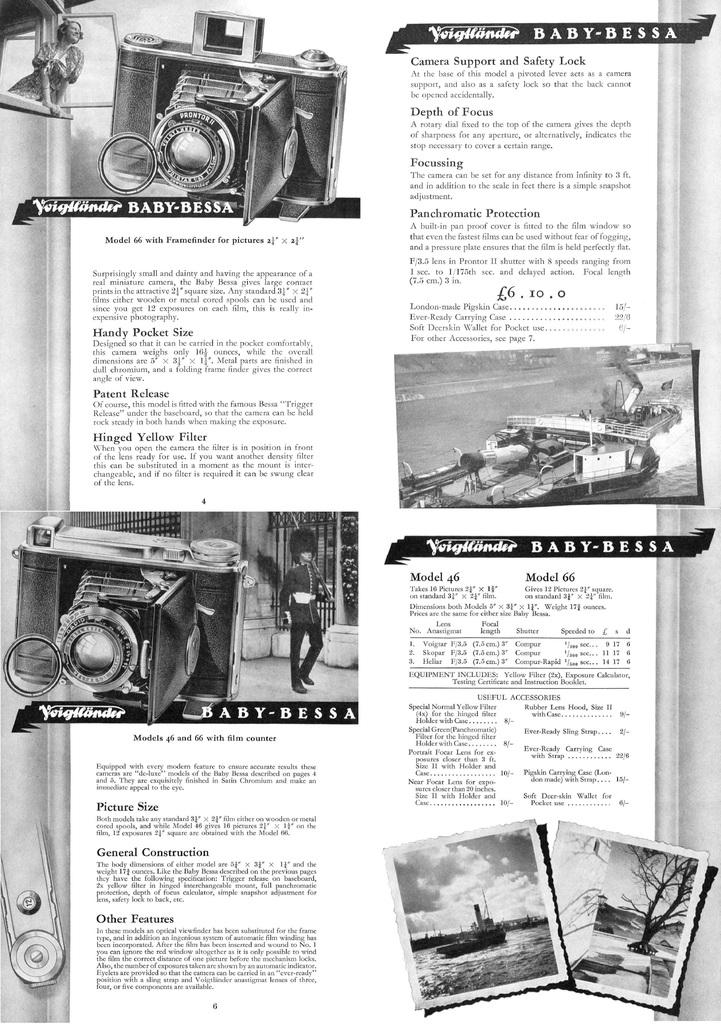What is the color scheme of the image? The image is black and white. What type of object with text can be seen in the image? There is a paper with text in the image. What else is present in the image besides the paper with text? There are pictures in the image. How many snakes can be seen slithering across the paper in the image? There are no snakes present in the image. What type of music is being played in the background of the image? There is no music present in the image, as it is a still image with no audio component. 